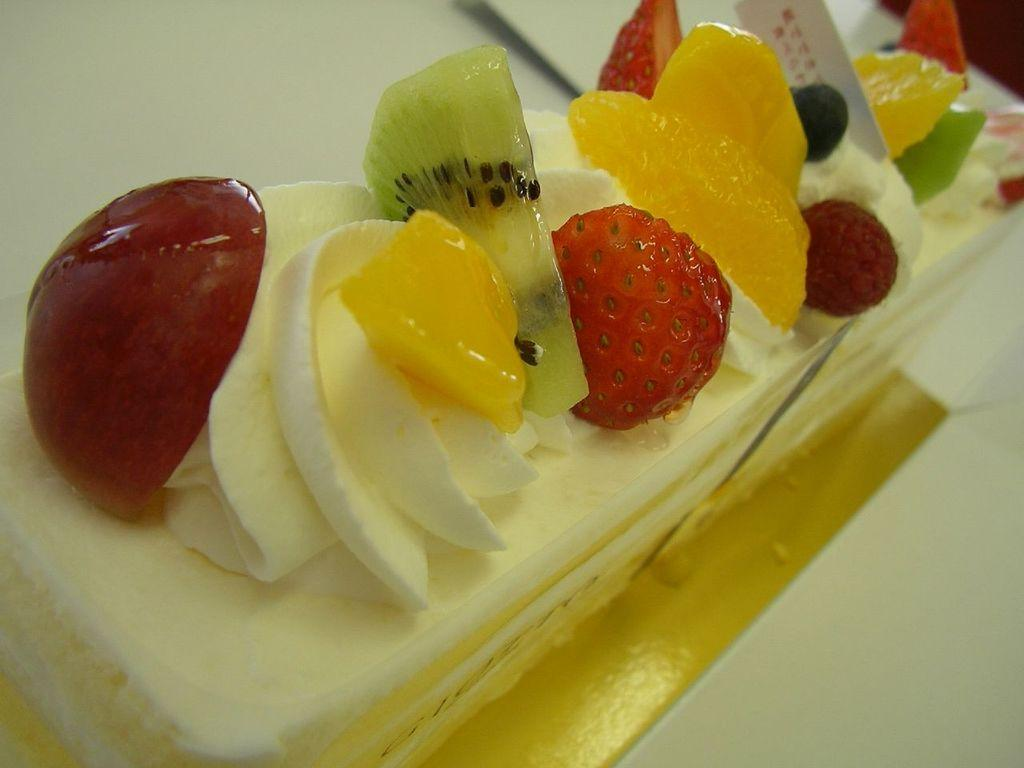What type of dessert is visible in the image? There is a piece of cake in the image. What fruits are present on the cake? The cake has strawberries, cherries, pineapple, and kiwi fruit on it. What type of cork can be seen in the image? There is no cork present in the image. Can you see a yard in the image? There is no yard visible in the image; it features a piece of cake with various fruits on it. 